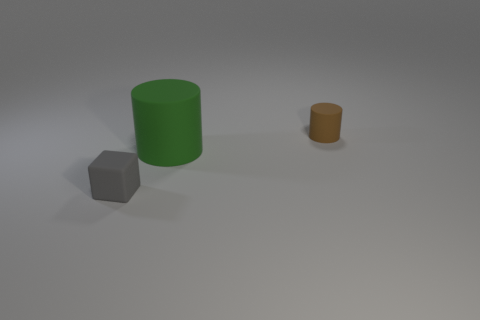Add 2 large blue rubber cylinders. How many objects exist? 5 Subtract 2 cylinders. How many cylinders are left? 0 Subtract all red balls. How many green cylinders are left? 1 Subtract 1 brown cylinders. How many objects are left? 2 Subtract all cylinders. How many objects are left? 1 Subtract all blue cylinders. Subtract all blue blocks. How many cylinders are left? 2 Subtract all large cylinders. Subtract all tiny red blocks. How many objects are left? 2 Add 1 blocks. How many blocks are left? 2 Add 2 large blue metallic cylinders. How many large blue metallic cylinders exist? 2 